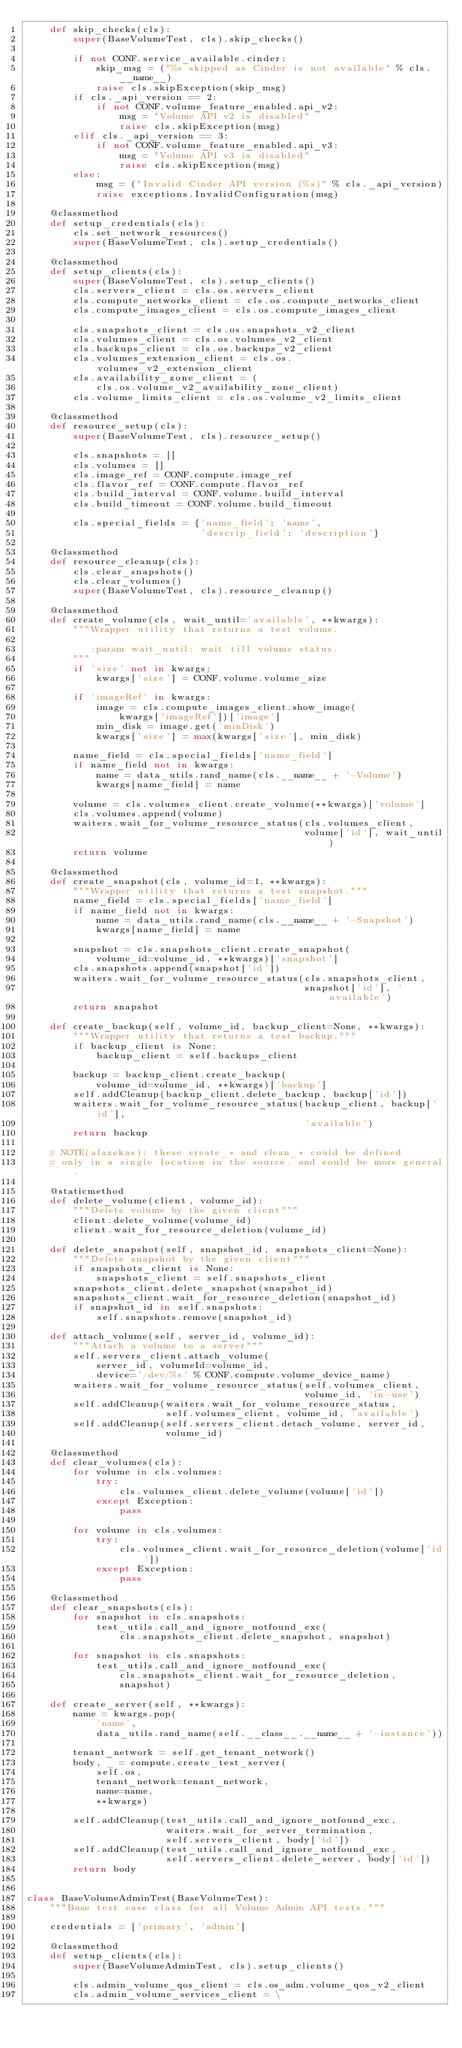<code> <loc_0><loc_0><loc_500><loc_500><_Python_>    def skip_checks(cls):
        super(BaseVolumeTest, cls).skip_checks()

        if not CONF.service_available.cinder:
            skip_msg = ("%s skipped as Cinder is not available" % cls.__name__)
            raise cls.skipException(skip_msg)
        if cls._api_version == 2:
            if not CONF.volume_feature_enabled.api_v2:
                msg = "Volume API v2 is disabled"
                raise cls.skipException(msg)
        elif cls._api_version == 3:
            if not CONF.volume_feature_enabled.api_v3:
                msg = "Volume API v3 is disabled"
                raise cls.skipException(msg)
        else:
            msg = ("Invalid Cinder API version (%s)" % cls._api_version)
            raise exceptions.InvalidConfiguration(msg)

    @classmethod
    def setup_credentials(cls):
        cls.set_network_resources()
        super(BaseVolumeTest, cls).setup_credentials()

    @classmethod
    def setup_clients(cls):
        super(BaseVolumeTest, cls).setup_clients()
        cls.servers_client = cls.os.servers_client
        cls.compute_networks_client = cls.os.compute_networks_client
        cls.compute_images_client = cls.os.compute_images_client

        cls.snapshots_client = cls.os.snapshots_v2_client
        cls.volumes_client = cls.os.volumes_v2_client
        cls.backups_client = cls.os.backups_v2_client
        cls.volumes_extension_client = cls.os.volumes_v2_extension_client
        cls.availability_zone_client = (
            cls.os.volume_v2_availability_zone_client)
        cls.volume_limits_client = cls.os.volume_v2_limits_client

    @classmethod
    def resource_setup(cls):
        super(BaseVolumeTest, cls).resource_setup()

        cls.snapshots = []
        cls.volumes = []
        cls.image_ref = CONF.compute.image_ref
        cls.flavor_ref = CONF.compute.flavor_ref
        cls.build_interval = CONF.volume.build_interval
        cls.build_timeout = CONF.volume.build_timeout

        cls.special_fields = {'name_field': 'name',
                              'descrip_field': 'description'}

    @classmethod
    def resource_cleanup(cls):
        cls.clear_snapshots()
        cls.clear_volumes()
        super(BaseVolumeTest, cls).resource_cleanup()

    @classmethod
    def create_volume(cls, wait_until='available', **kwargs):
        """Wrapper utility that returns a test volume.

           :param wait_until: wait till volume status.
        """
        if 'size' not in kwargs:
            kwargs['size'] = CONF.volume.volume_size

        if 'imageRef' in kwargs:
            image = cls.compute_images_client.show_image(
                kwargs['imageRef'])['image']
            min_disk = image.get('minDisk')
            kwargs['size'] = max(kwargs['size'], min_disk)

        name_field = cls.special_fields['name_field']
        if name_field not in kwargs:
            name = data_utils.rand_name(cls.__name__ + '-Volume')
            kwargs[name_field] = name

        volume = cls.volumes_client.create_volume(**kwargs)['volume']
        cls.volumes.append(volume)
        waiters.wait_for_volume_resource_status(cls.volumes_client,
                                                volume['id'], wait_until)
        return volume

    @classmethod
    def create_snapshot(cls, volume_id=1, **kwargs):
        """Wrapper utility that returns a test snapshot."""
        name_field = cls.special_fields['name_field']
        if name_field not in kwargs:
            name = data_utils.rand_name(cls.__name__ + '-Snapshot')
            kwargs[name_field] = name

        snapshot = cls.snapshots_client.create_snapshot(
            volume_id=volume_id, **kwargs)['snapshot']
        cls.snapshots.append(snapshot['id'])
        waiters.wait_for_volume_resource_status(cls.snapshots_client,
                                                snapshot['id'], 'available')
        return snapshot

    def create_backup(self, volume_id, backup_client=None, **kwargs):
        """Wrapper utility that returns a test backup."""
        if backup_client is None:
            backup_client = self.backups_client

        backup = backup_client.create_backup(
            volume_id=volume_id, **kwargs)['backup']
        self.addCleanup(backup_client.delete_backup, backup['id'])
        waiters.wait_for_volume_resource_status(backup_client, backup['id'],
                                                'available')
        return backup

    # NOTE(afazekas): these create_* and clean_* could be defined
    # only in a single location in the source, and could be more general.

    @staticmethod
    def delete_volume(client, volume_id):
        """Delete volume by the given client"""
        client.delete_volume(volume_id)
        client.wait_for_resource_deletion(volume_id)

    def delete_snapshot(self, snapshot_id, snapshots_client=None):
        """Delete snapshot by the given client"""
        if snapshots_client is None:
            snapshots_client = self.snapshots_client
        snapshots_client.delete_snapshot(snapshot_id)
        snapshots_client.wait_for_resource_deletion(snapshot_id)
        if snapshot_id in self.snapshots:
            self.snapshots.remove(snapshot_id)

    def attach_volume(self, server_id, volume_id):
        """Attach a volume to a server"""
        self.servers_client.attach_volume(
            server_id, volumeId=volume_id,
            device='/dev/%s' % CONF.compute.volume_device_name)
        waiters.wait_for_volume_resource_status(self.volumes_client,
                                                volume_id, 'in-use')
        self.addCleanup(waiters.wait_for_volume_resource_status,
                        self.volumes_client, volume_id, 'available')
        self.addCleanup(self.servers_client.detach_volume, server_id,
                        volume_id)

    @classmethod
    def clear_volumes(cls):
        for volume in cls.volumes:
            try:
                cls.volumes_client.delete_volume(volume['id'])
            except Exception:
                pass

        for volume in cls.volumes:
            try:
                cls.volumes_client.wait_for_resource_deletion(volume['id'])
            except Exception:
                pass

    @classmethod
    def clear_snapshots(cls):
        for snapshot in cls.snapshots:
            test_utils.call_and_ignore_notfound_exc(
                cls.snapshots_client.delete_snapshot, snapshot)

        for snapshot in cls.snapshots:
            test_utils.call_and_ignore_notfound_exc(
                cls.snapshots_client.wait_for_resource_deletion,
                snapshot)

    def create_server(self, **kwargs):
        name = kwargs.pop(
            'name',
            data_utils.rand_name(self.__class__.__name__ + '-instance'))

        tenant_network = self.get_tenant_network()
        body, _ = compute.create_test_server(
            self.os,
            tenant_network=tenant_network,
            name=name,
            **kwargs)

        self.addCleanup(test_utils.call_and_ignore_notfound_exc,
                        waiters.wait_for_server_termination,
                        self.servers_client, body['id'])
        self.addCleanup(test_utils.call_and_ignore_notfound_exc,
                        self.servers_client.delete_server, body['id'])
        return body


class BaseVolumeAdminTest(BaseVolumeTest):
    """Base test case class for all Volume Admin API tests."""

    credentials = ['primary', 'admin']

    @classmethod
    def setup_clients(cls):
        super(BaseVolumeAdminTest, cls).setup_clients()

        cls.admin_volume_qos_client = cls.os_adm.volume_qos_v2_client
        cls.admin_volume_services_client = \</code> 